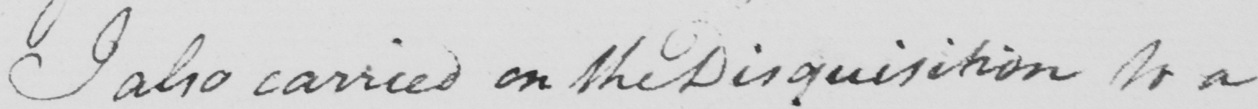What text is written in this handwritten line? I also carried on the Disquisition to a 